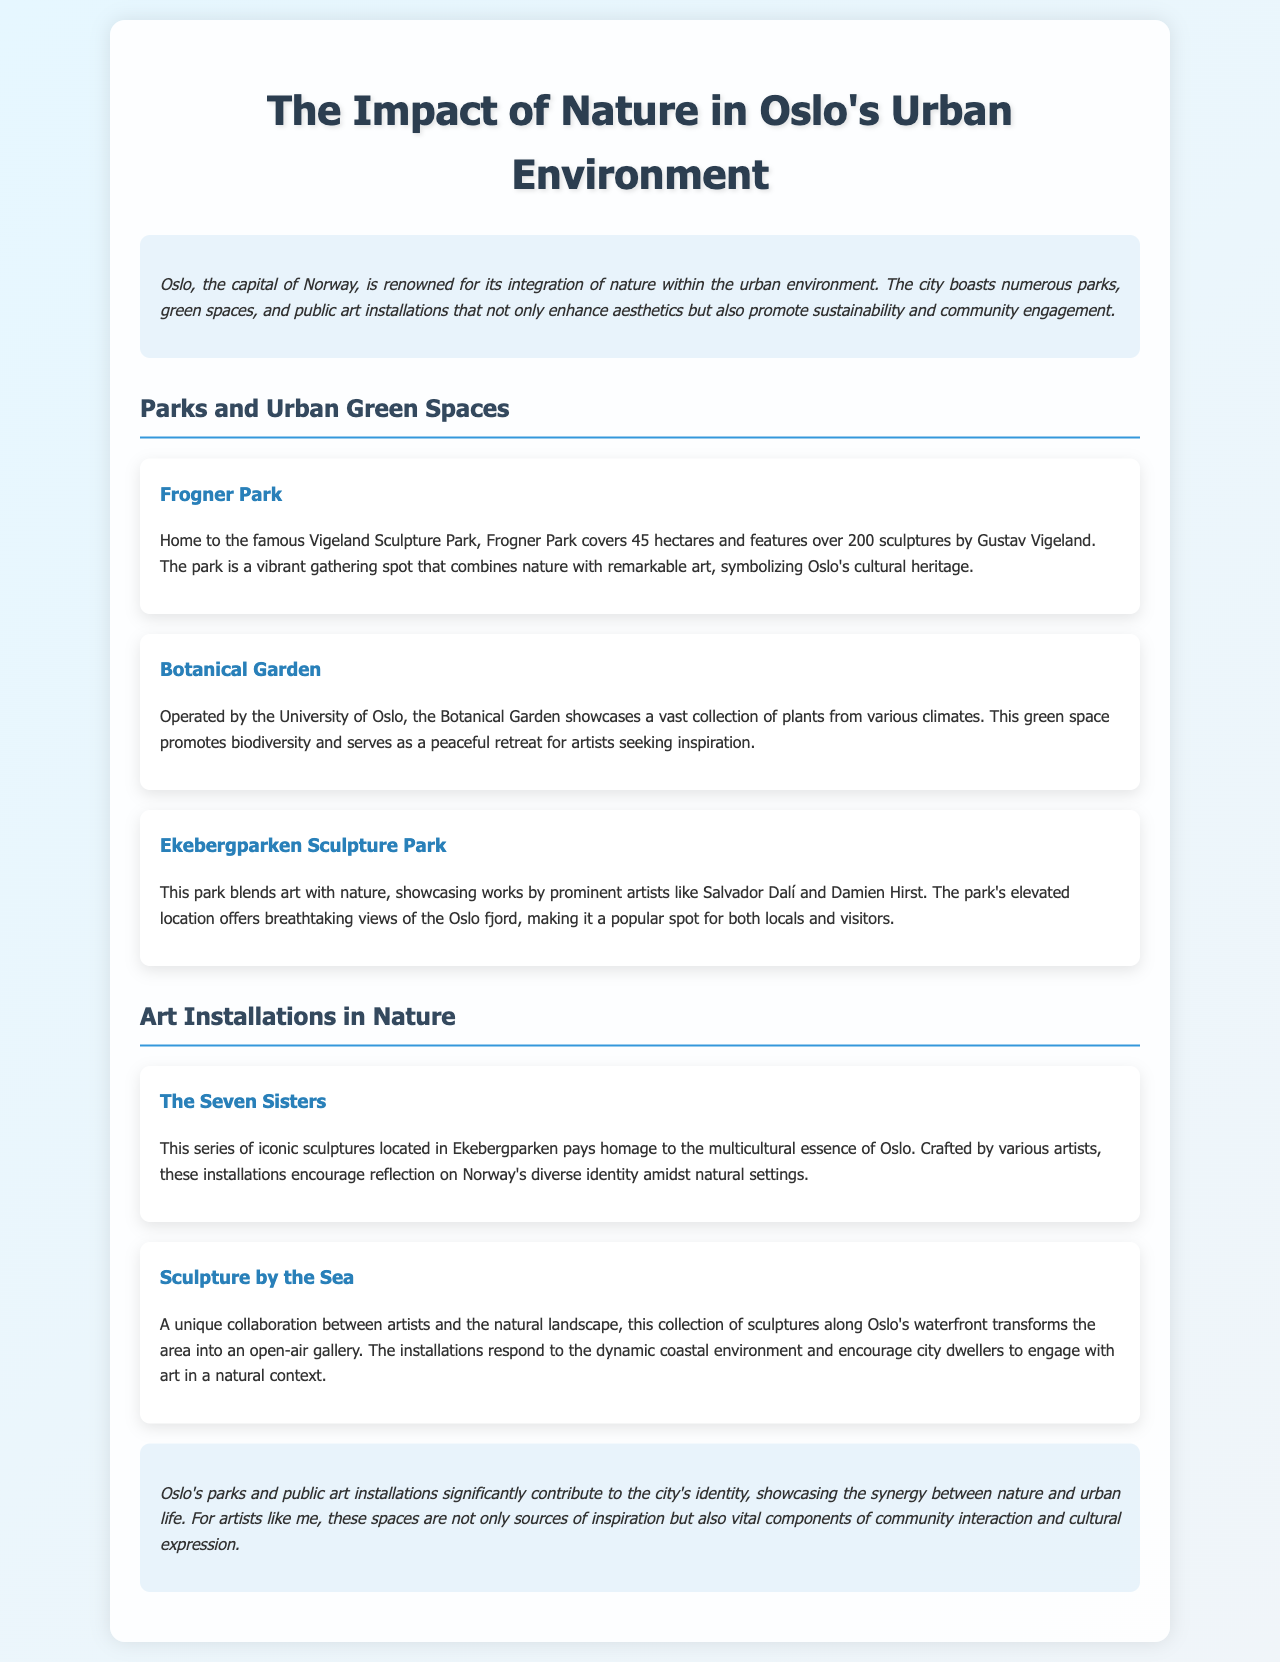What is the area of Frogner Park? The area of Frogner Park is mentioned as covering 45 hectares.
Answer: 45 hectares What notable artist's works are featured in Ekebergparken Sculpture Park? The document states that Ekebergparken showcases works by prominent artists like Salvador Dalí and Damien Hirst.
Answer: Salvador Dalí and Damien Hirst What is the significance of The Seven Sisters sculptures? The Seven Sisters sculptures pay homage to the multicultural essence of Oslo, crafted by various artists.
Answer: Multicultural essence of Oslo Which park features the Vigeland Sculpture Park? The document identifies Frogner Park as home to the famous Vigeland Sculpture Park.
Answer: Frogner Park How does Sculpture by the Sea engage with the environment? The document describes Sculpture by the Sea as transforming the waterfront area into an open-air gallery, responding to the dynamic coastal environment.
Answer: Open-air gallery What purpose does the Botanical Garden serve for artists? The Botanical Garden is described as a peaceful retreat for artists seeking inspiration.
Answer: Peaceful retreat What is a key theme of Oslo's urban parks and installations? The conclusion states that Oslo's parks and public art installations significantly contribute to the city's identity.
Answer: City identity How many sculptures are featured in Frogner Park? The document mentions that Frogner Park features over 200 sculptures by Gustav Vigeland.
Answer: Over 200 sculptures 